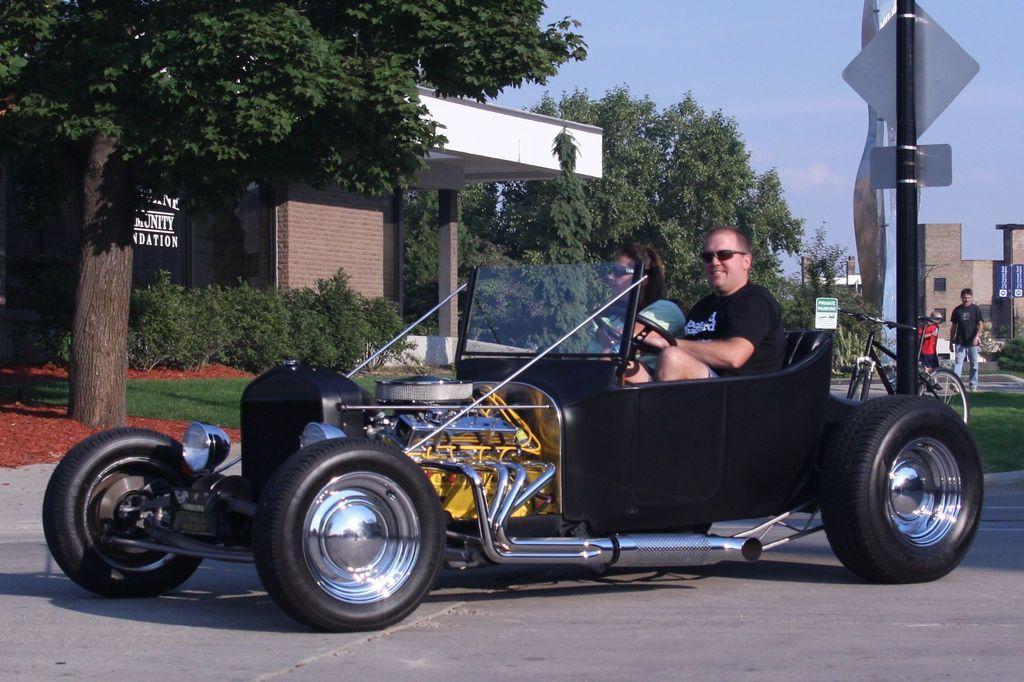In one or two sentences, can you explain what this image depicts? this picture shows a car where two people Seated on it and we see see a man walking on the sidewalk and we see a bicycle and we see few houses and couple of trees. 